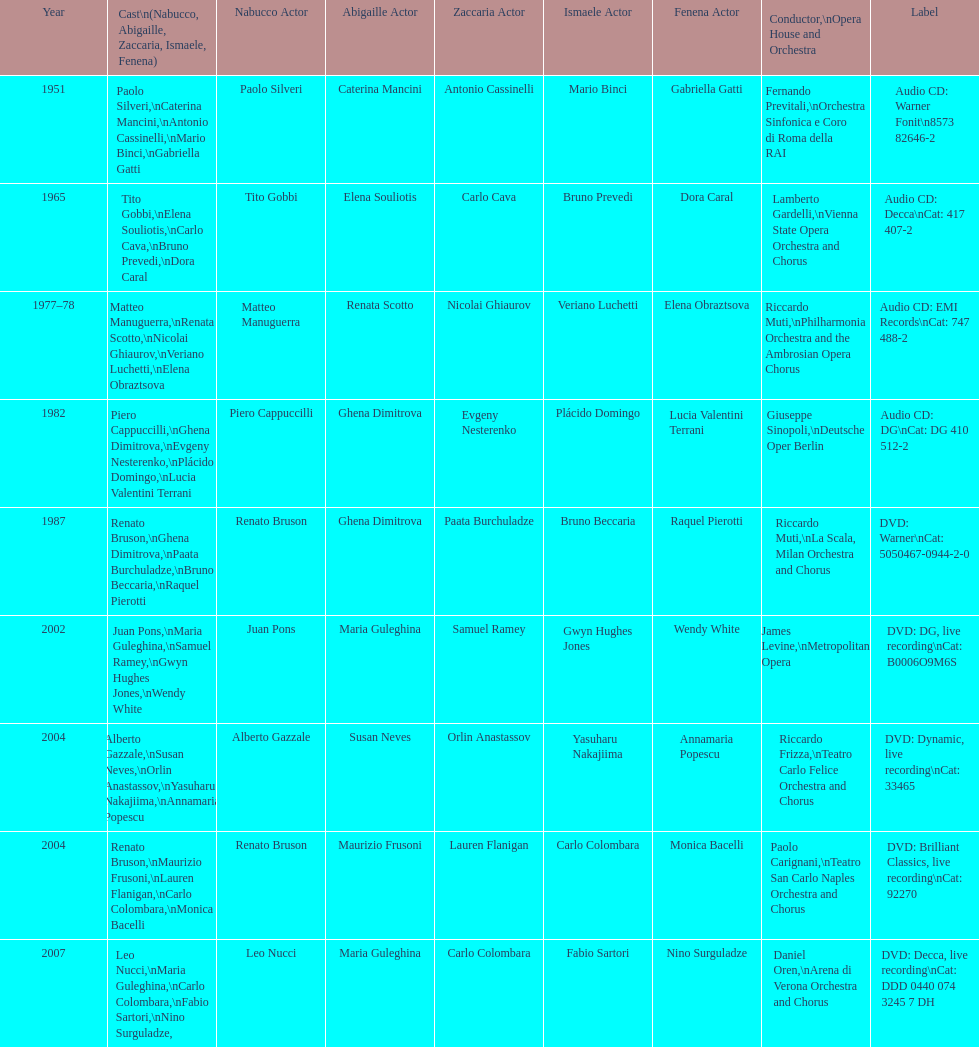How many recordings of nabucco have been made? 9. 